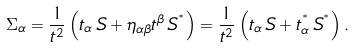<formula> <loc_0><loc_0><loc_500><loc_500>\Sigma _ { \alpha } = { \frac { 1 } { t ^ { 2 } } } \left ( t _ { \alpha } \, S + \eta _ { \alpha \beta } t ^ { \beta } \, S ^ { ^ { * } } \right ) = { \frac { 1 } { t ^ { 2 } } } \left ( t _ { \alpha } \, S + t _ { \alpha } ^ { ^ { * } } \, S ^ { ^ { * } } \right ) .</formula> 